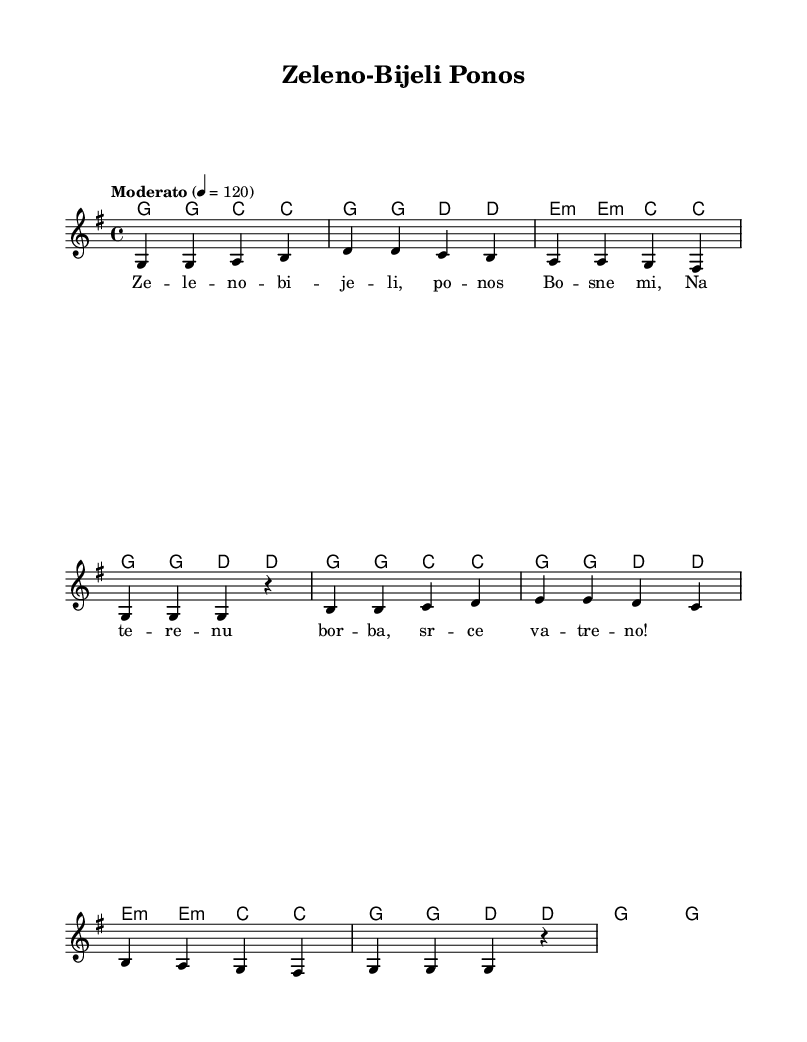What is the key signature of this music? The key signature indicated at the beginning of the sheet music is G major, which has one sharp (F#).
Answer: G major What is the time signature of this piece? The time signature is represented by the two numbers at the beginning of the music, where the top number is 4 and the bottom number is also 4, indicating four beats per measure.
Answer: 4/4 What is the tempo marking provided for this piece? The tempo marking is at the start of the score, stating "Moderato," which indicates a moderate pace. The metronome mark is given as "4 = 120," meaning there are 120 beats per minute.
Answer: Moderato How many measures does the melody have? Counting the melody line, we see that there are a total of 8 measures presented in the music sheet.
Answer: 8 What is the first lyric line of the verse? The first line of the lyrics, which is aligned with the melody notation, reads "Ze -- le -- no -- bi -- je -- li, po -- nos Bo -- sne mi," shown directly beneath the melody notes.
Answer: Ze -- le -- no -- bi -- je -- li, po -- nos Bo -- sne mi What is the harmonic progression for the first two measures? Observing the chord mode under the melody, the harmonic progression indicated for the first two measures is G major and G major.
Answer: G major, G major What type of song is this likely to be, based on its lyrical and musical qualities? Given the cultural references and style, this song is likely a folk-inspired football chant or anthem, characterized by its simple yet catchy melody and lyrics meant for group singing.
Answer: Folk-inspired football chant 